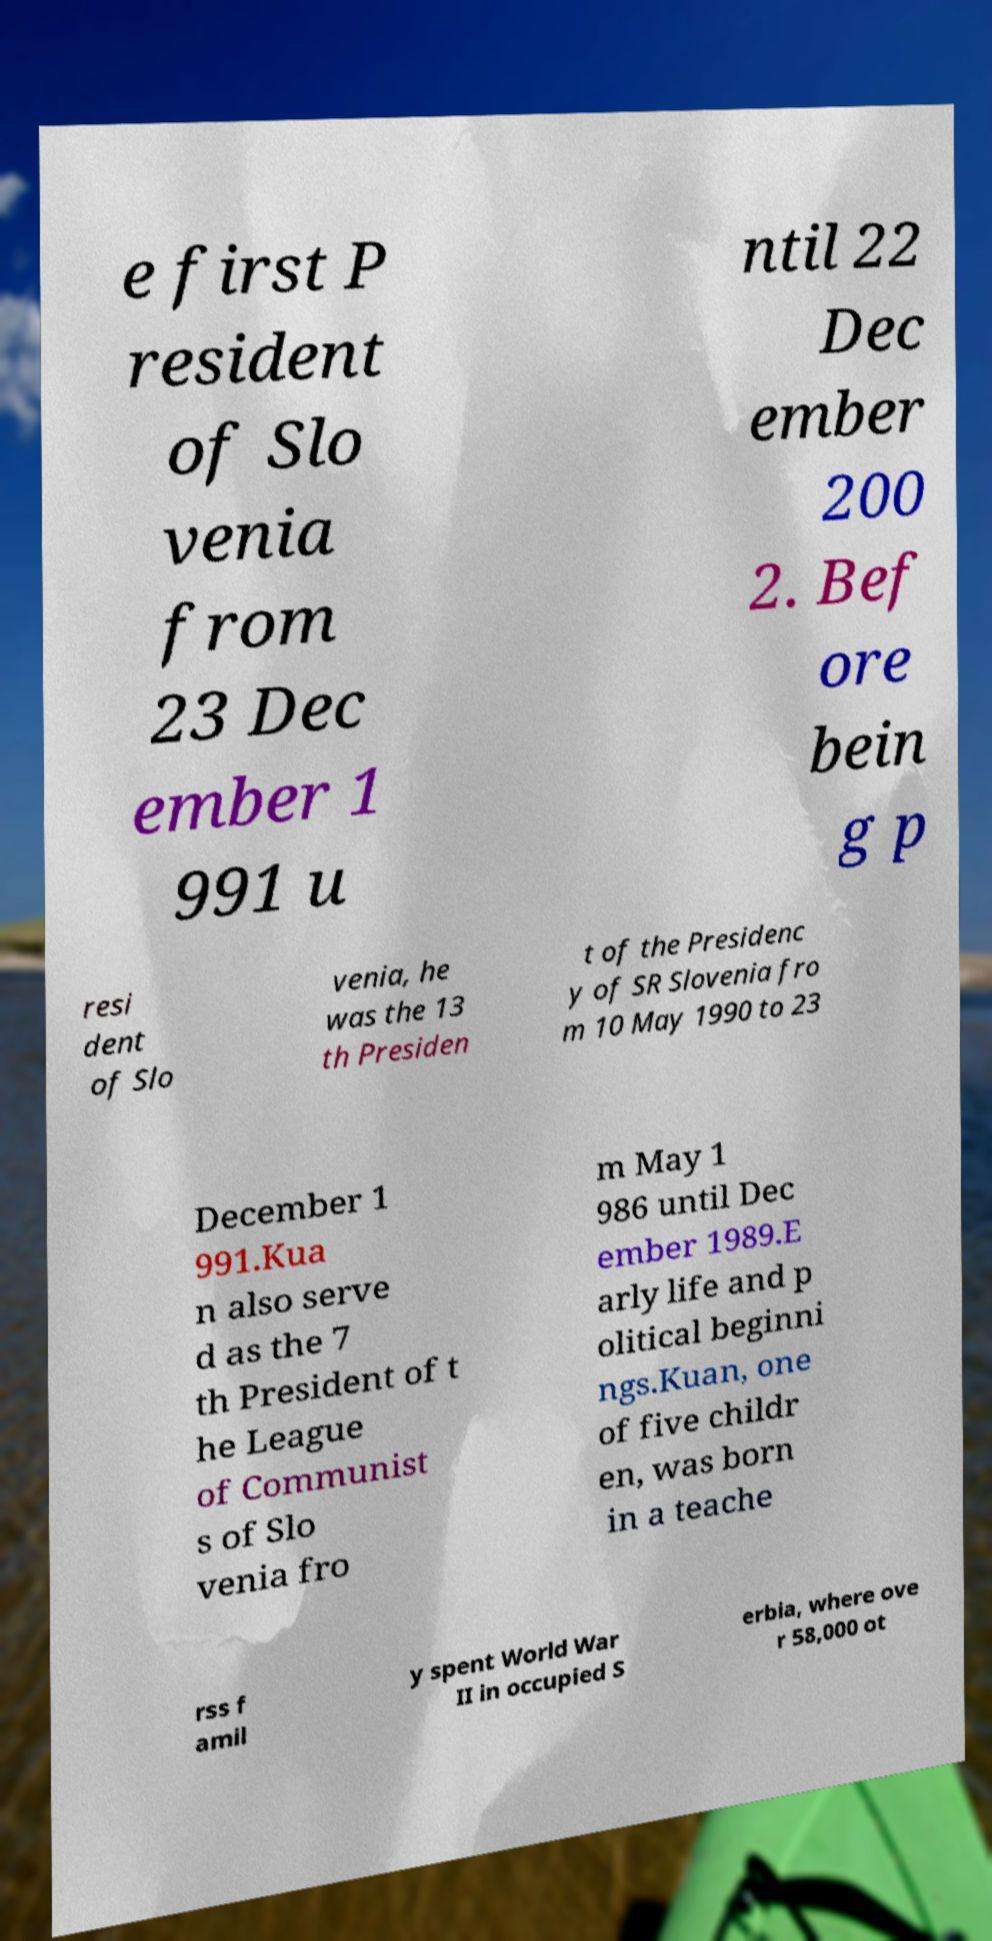Could you extract and type out the text from this image? e first P resident of Slo venia from 23 Dec ember 1 991 u ntil 22 Dec ember 200 2. Bef ore bein g p resi dent of Slo venia, he was the 13 th Presiden t of the Presidenc y of SR Slovenia fro m 10 May 1990 to 23 December 1 991.Kua n also serve d as the 7 th President of t he League of Communist s of Slo venia fro m May 1 986 until Dec ember 1989.E arly life and p olitical beginni ngs.Kuan, one of five childr en, was born in a teache rss f amil y spent World War II in occupied S erbia, where ove r 58,000 ot 